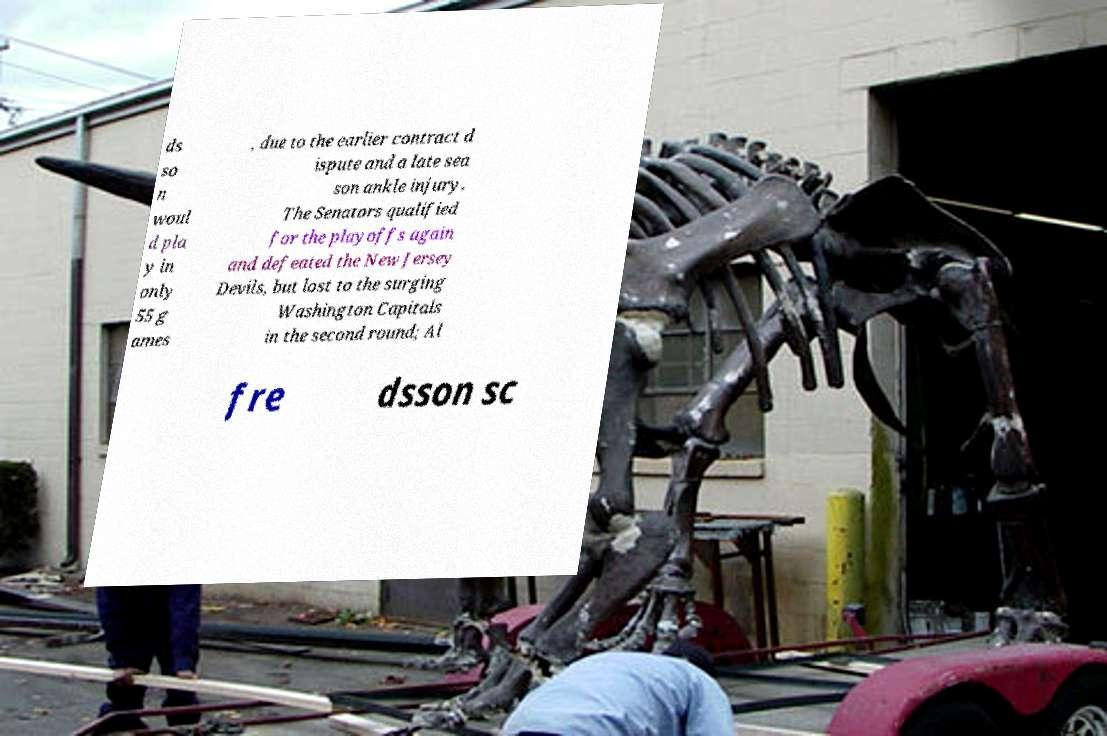I need the written content from this picture converted into text. Can you do that? ds so n woul d pla y in only 55 g ames , due to the earlier contract d ispute and a late sea son ankle injury. The Senators qualified for the playoffs again and defeated the New Jersey Devils, but lost to the surging Washington Capitals in the second round; Al fre dsson sc 